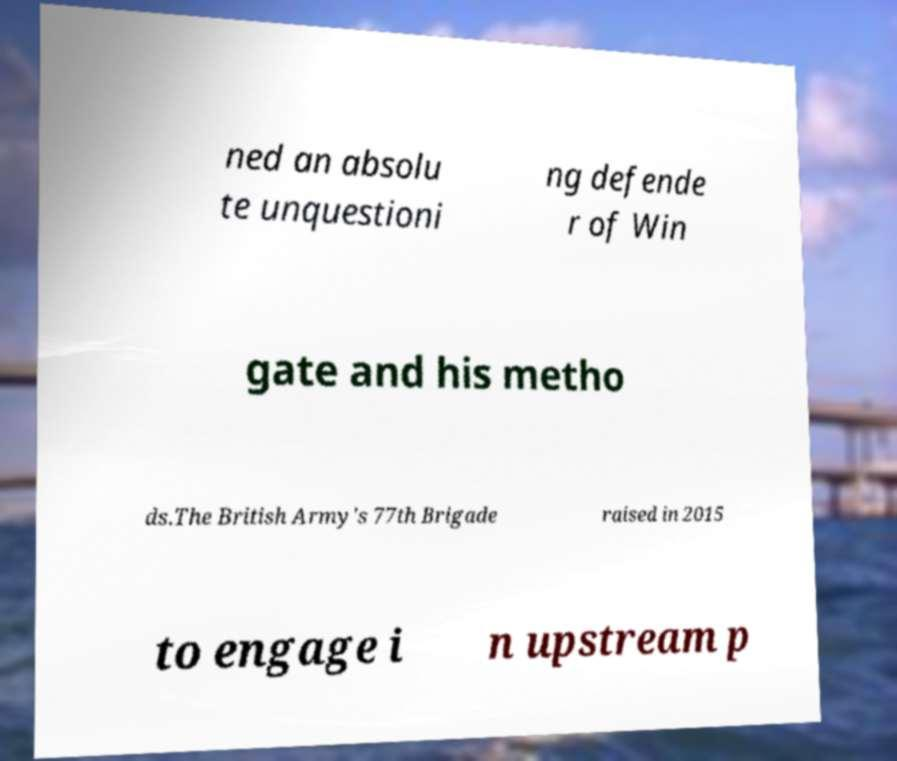I need the written content from this picture converted into text. Can you do that? ned an absolu te unquestioni ng defende r of Win gate and his metho ds.The British Army's 77th Brigade raised in 2015 to engage i n upstream p 